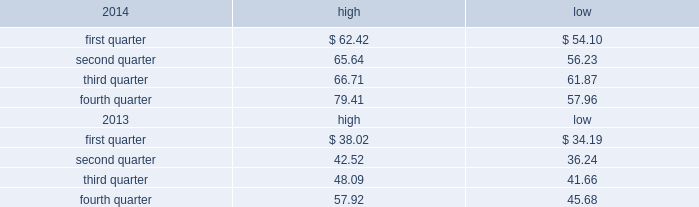Part ii item 5 .
Market for registrant 2019s common equity , related stockholder matters and issuer purchases of equity securities market price of and dividends on the registrant 2019s common equity and related stockholder matters market information .
Our class a common stock is quoted on the nasdaq global select market under the symbol 201cdish . 201d the high and low closing sale prices of our class a common stock during 2014 and 2013 on the nasdaq global select market ( as reported by nasdaq ) are set forth below. .
As of february 13 , 2015 , there were approximately 8208 holders of record of our class a common stock , not including stockholders who beneficially own class a common stock held in nominee or street name .
As of february 10 , 2015 , 213247004 of the 238435208 outstanding shares of our class b common stock were beneficially held by charles w .
Ergen , our chairman , and the remaining 25188204 were held in trusts established by mr .
Ergen for the benefit of his family .
There is currently no trading market for our class b common stock .
Dividends .
On december 28 , 2012 , we paid a cash dividend of $ 1.00 per share , or approximately $ 453 million , on our outstanding class a and class b common stock to stockholders of record at the close of business on december 14 , 2012 .
While we currently do not intend to declare additional dividends on our common stock , we may elect to do so from time to time .
Payment of any future dividends will depend upon our earnings and capital requirements , restrictions in our debt facilities , and other factors the board of directors considers appropriate .
We currently intend to retain our earnings , if any , to support future growth and expansion , although we may repurchase shares of our common stock from time to time .
See further discussion under 201citem 7 .
Management 2019s discussion and analysis of financial condition and results of operations 2013 liquidity and capital resources 201d in this annual report on form 10-k .
Securities authorized for issuance under equity compensation plans .
See 201citem 12 .
Security ownership of certain beneficial owners and management and related stockholder matters 201d in this annual report on form 10-k. .
What is the grow rate in the price of class a common stock in the fourth quarter of 2014 compare to the same quarter of 2013 , if we take into accounting the highest prices in both periods? 
Computations: ((79.41 - 57.92) / 57.92)
Answer: 0.37103. 